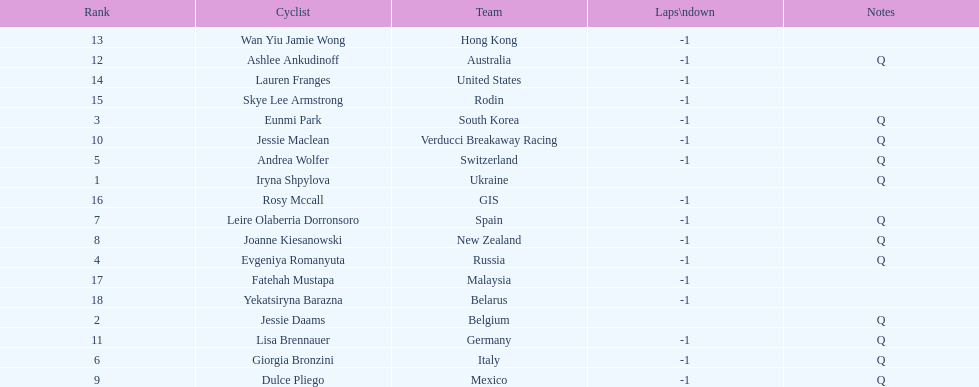How many consecutive notes are there? 12. 